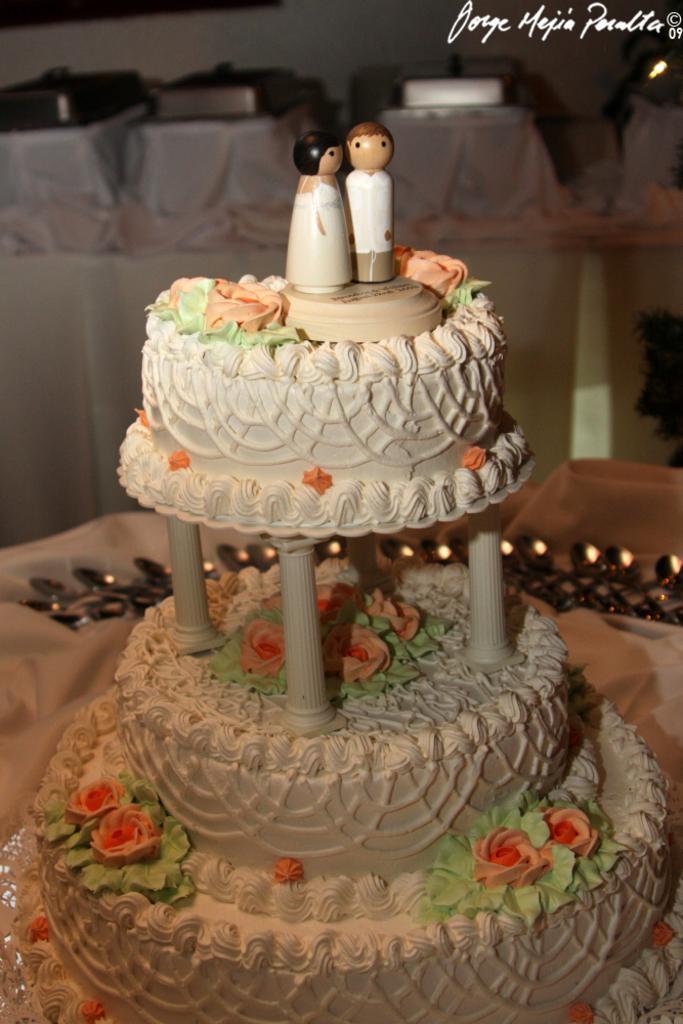Describe this image in one or two sentences. In this image I can see a cake on a table. In the background I can see some objects. Here I can see a watermark. 